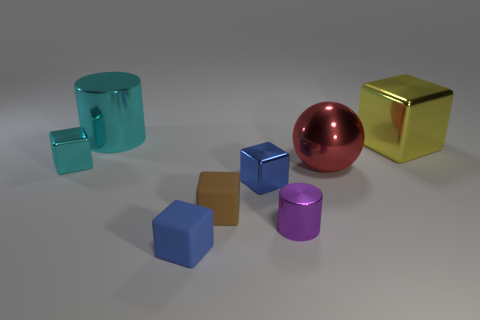Does the blue thing in front of the brown object have the same shape as the big cyan shiny object?
Offer a very short reply. No. What number of small objects are left of the small metallic cylinder and right of the small brown matte block?
Your answer should be compact. 1. How many other things are the same size as the red metallic ball?
Give a very brief answer. 2. Are there an equal number of big blocks to the left of the big red metal ball and yellow cylinders?
Your answer should be compact. Yes. Does the small thing to the left of the cyan cylinder have the same color as the large object to the left of the blue metallic object?
Provide a short and direct response. Yes. What material is the object that is behind the tiny cyan block and to the left of the small blue matte cube?
Make the answer very short. Metal. What is the color of the big metallic block?
Your response must be concise. Yellow. How many other objects are there of the same shape as the large red metallic thing?
Your answer should be very brief. 0. Is the number of big cyan things that are in front of the blue metallic thing the same as the number of small cyan metallic things to the right of the large cyan shiny cylinder?
Your answer should be very brief. Yes. What is the material of the brown block?
Provide a succinct answer. Rubber. 